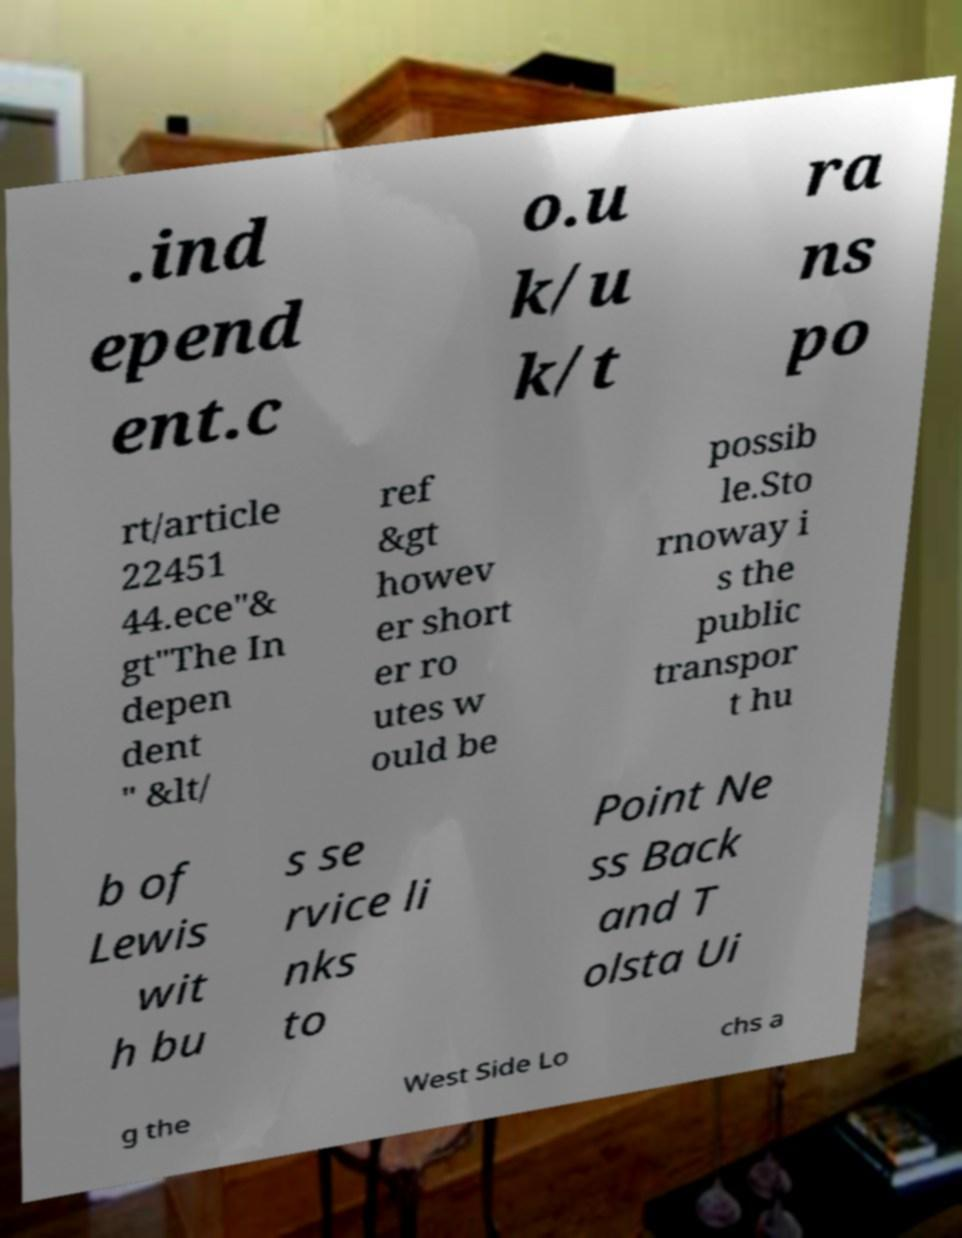Please read and relay the text visible in this image. What does it say? .ind epend ent.c o.u k/u k/t ra ns po rt/article 22451 44.ece"& gt"The In depen dent " &lt/ ref &gt howev er short er ro utes w ould be possib le.Sto rnoway i s the public transpor t hu b of Lewis wit h bu s se rvice li nks to Point Ne ss Back and T olsta Ui g the West Side Lo chs a 